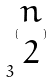Convert formula to latex. <formula><loc_0><loc_0><loc_500><loc_500>3 ^ { ( \begin{matrix} n \\ 2 \end{matrix} ) }</formula> 